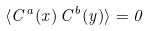<formula> <loc_0><loc_0><loc_500><loc_500>\langle C ^ { a } ( x ) \, C ^ { b } ( y ) \rangle = 0</formula> 